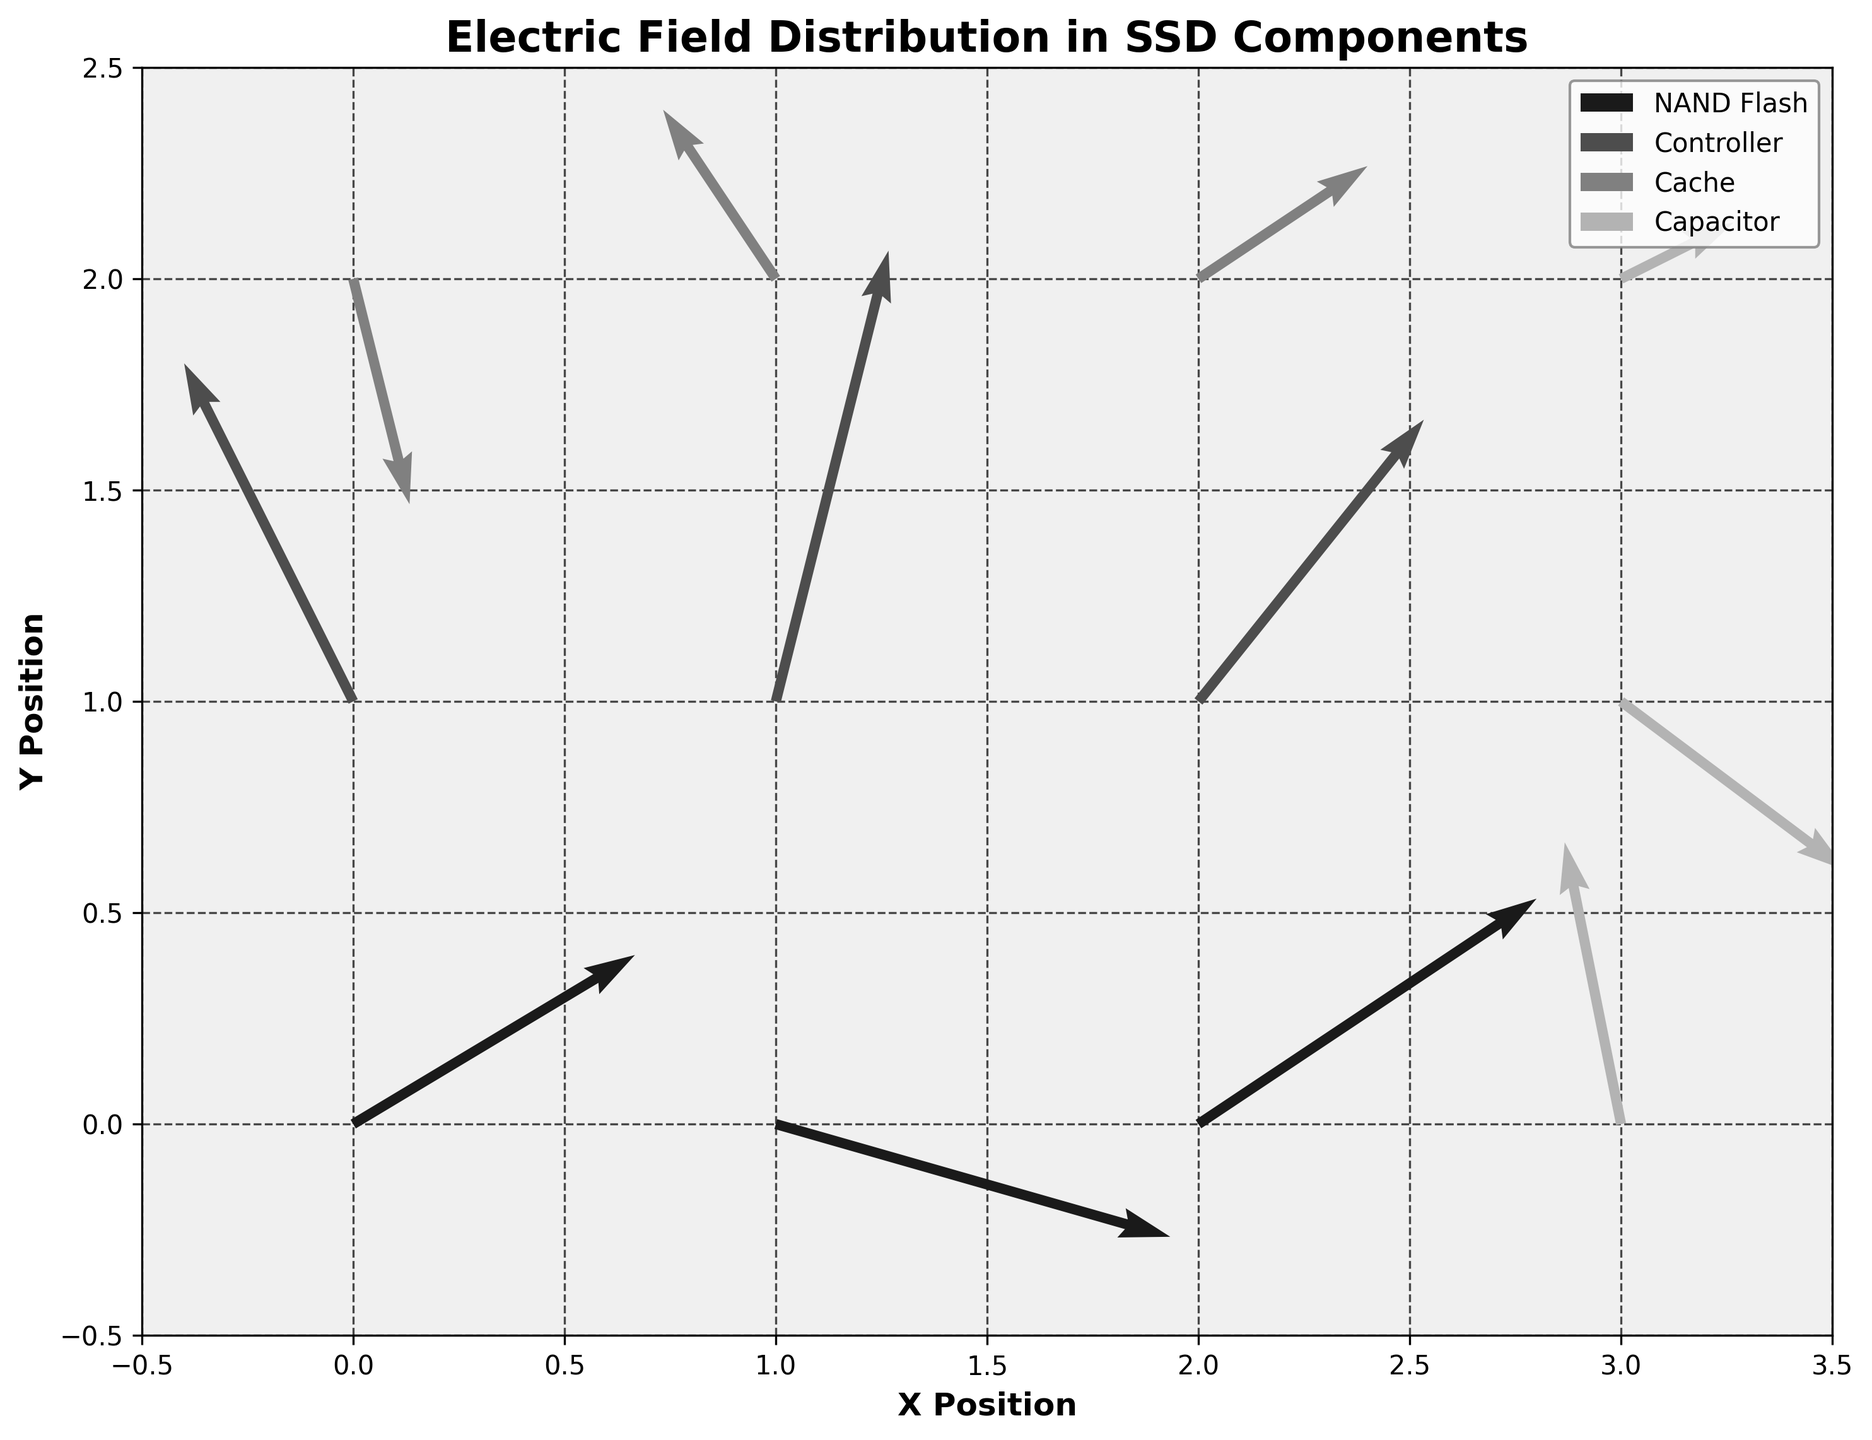What is the title of the plot? The title is displayed at the top of the plot. It provides a summary of what the plot represents.
Answer: Electric Field Distribution in SSD Components How many components are shown in the plot? The legend in the upper right corner lists the components represented.
Answer: Four Which component has the electric field vector at position (0,0)? Locate the point (0,0) on the plot and identify the component name from the legend color that matches the arrow at that position.
Answer: NAND Flash What are the x and y axis labels? The labels can be found along the axes of the plot. The x-axis label is below the horizontal axis, and the y-axis label is to the left of the vertical axis.
Answer: X Position, Y Position Compare the electric field direction at (1,0) and (1,1). Which vector is pointing more towards the negative y-axis? By observing the direction of the arrows at these positions, we can see which vector has a more negative y-component.
Answer: The vector at (1,0) What is the color used to represent 'Cache'? The legend shows the color used for each component, where 'Cache' is listed.
Answer: Light grey Which component has the largest electric field magnitude at (2,0)? Calculate the magnitude (sqrt(Ex^2 + Ey^2)) for the electric field at (2,0). Compare it to where the vector ends to identify the component from the legend.
Answer: NAND Flash What is the general trend of the electric field vectors' direction in the 'Controller' component region? Observe the vectors in the 'Controller' region and describe their general direction.
Answer: Mostly pointing upwards and to the right Which component has the most evenly distributed vector magnitudes based on the visual inspection? Look at the lengths of the vectors for each component and determine which has the vectors of similar length.
Answer: Cache How many vectors have a negative x-component? Count the number of vectors where the x-component (Ex) is negative.
Answer: Three 